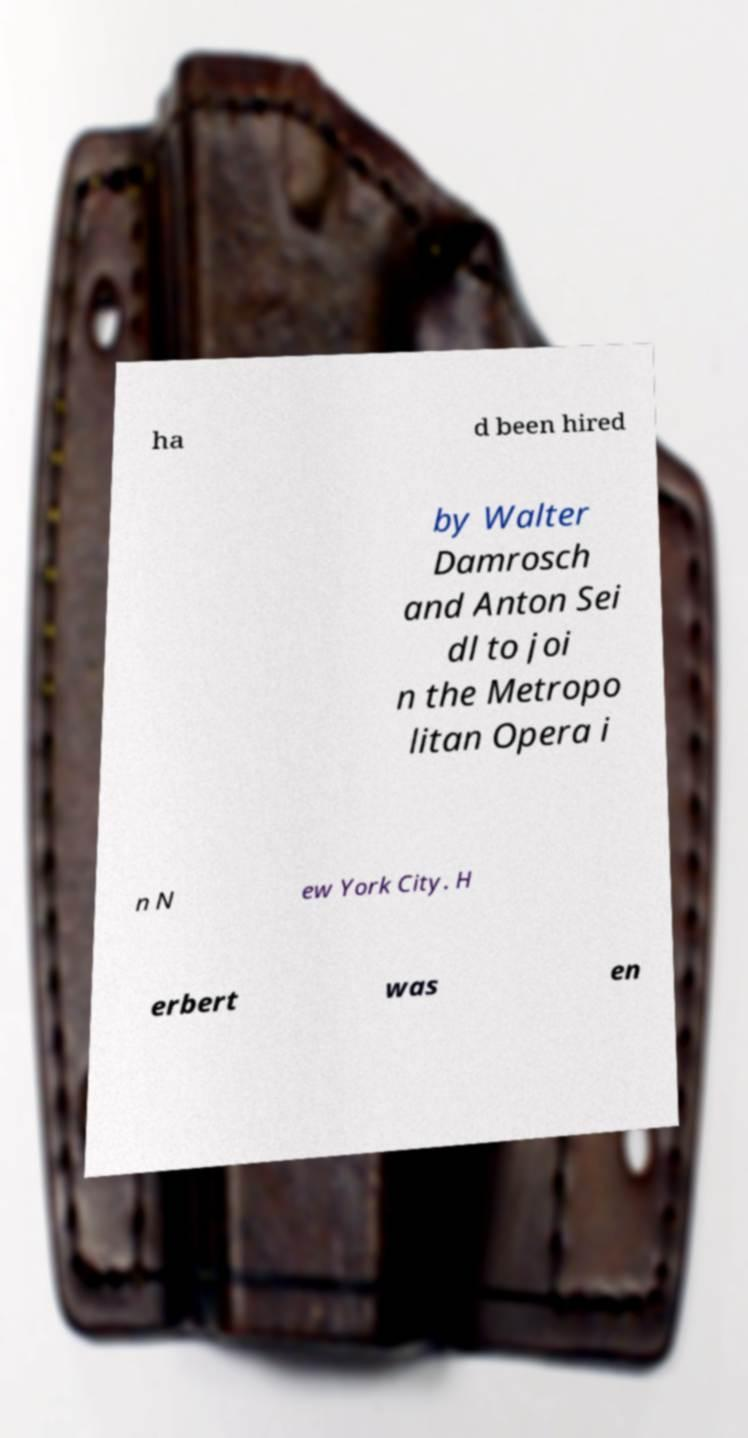Please identify and transcribe the text found in this image. ha d been hired by Walter Damrosch and Anton Sei dl to joi n the Metropo litan Opera i n N ew York City. H erbert was en 